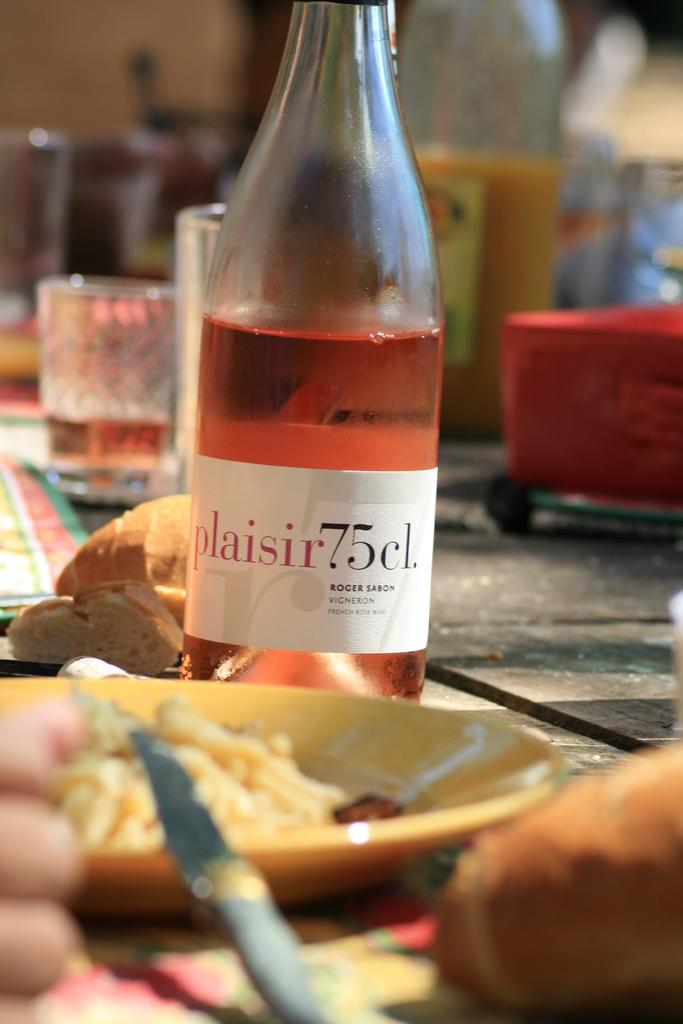<image>
Summarize the visual content of the image. A 75 centiliter bottle of Roger Sabon French rose wine with a white label on a table next to a dinner plate. 